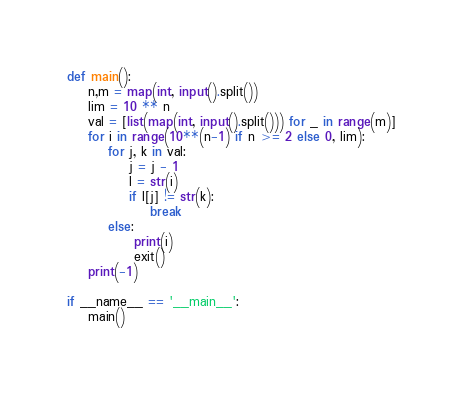Convert code to text. <code><loc_0><loc_0><loc_500><loc_500><_Python_>def main():
    n,m = map(int, input().split())
    lim = 10 ** n
    val = [list(map(int, input().split())) for _ in range(m)]
    for i in range(10**(n-1) if n >= 2 else 0, lim):
        for j, k in val:
            j = j - 1
            l = str(i)
            if l[j] != str(k):
                break
        else:
             print(i)
             exit()
    print(-1)

if __name__ == '__main__':
    main()
    </code> 